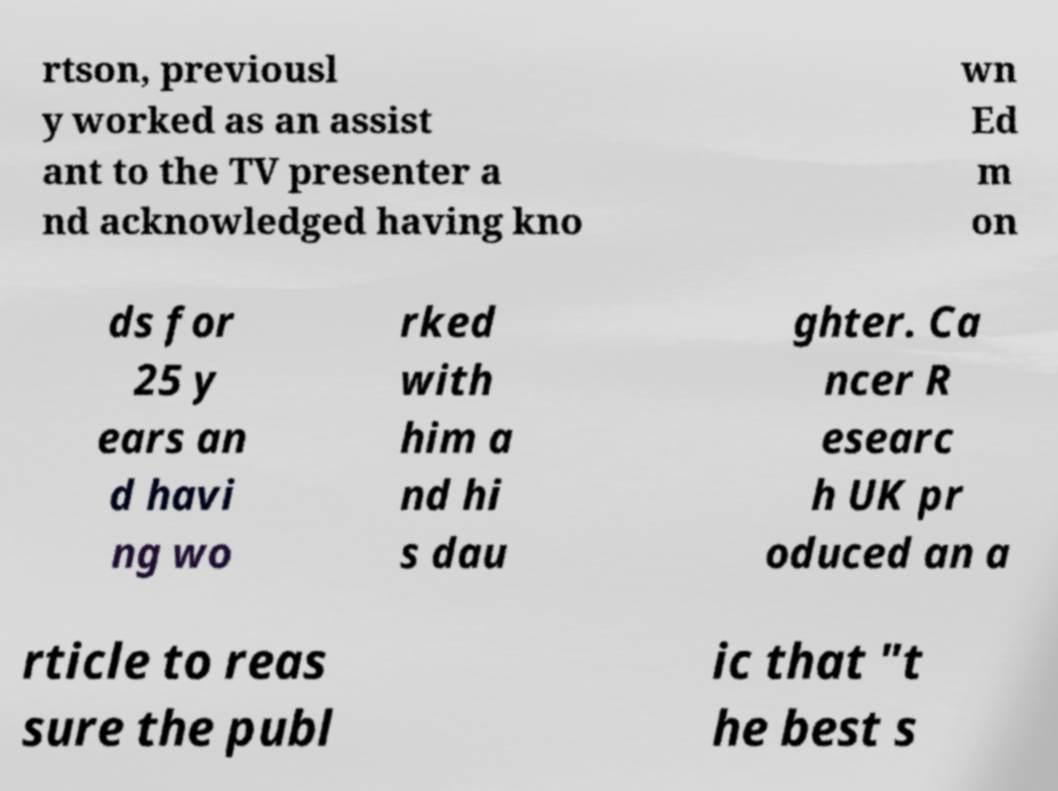There's text embedded in this image that I need extracted. Can you transcribe it verbatim? rtson, previousl y worked as an assist ant to the TV presenter a nd acknowledged having kno wn Ed m on ds for 25 y ears an d havi ng wo rked with him a nd hi s dau ghter. Ca ncer R esearc h UK pr oduced an a rticle to reas sure the publ ic that "t he best s 